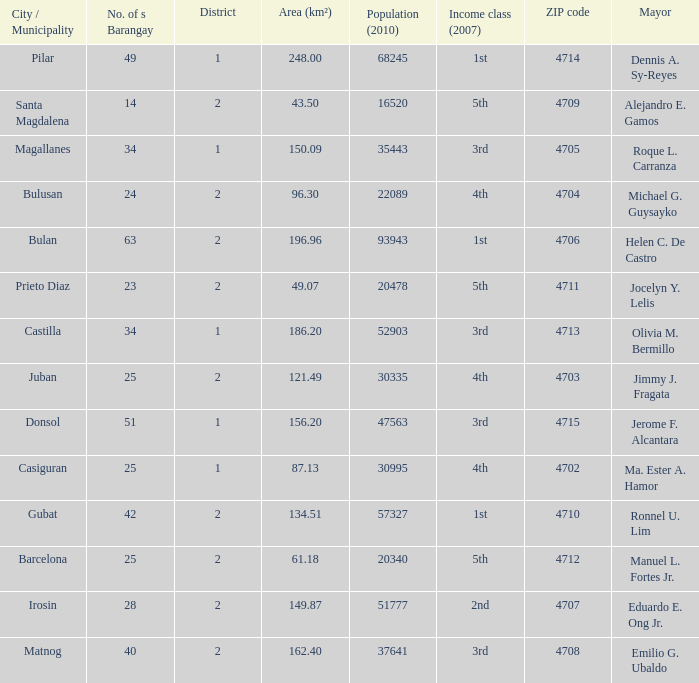What are all the metropolis / municipality where mayor is helen c. De castro Bulan. 